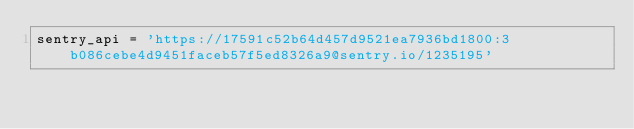<code> <loc_0><loc_0><loc_500><loc_500><_Python_>sentry_api = 'https://17591c52b64d457d9521ea7936bd1800:3b086cebe4d9451faceb57f5ed8326a9@sentry.io/1235195'
</code> 